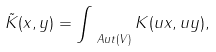Convert formula to latex. <formula><loc_0><loc_0><loc_500><loc_500>\tilde { K } ( x , y ) = \int _ { \ A u t ( V ) } K ( u x , u y ) ,</formula> 